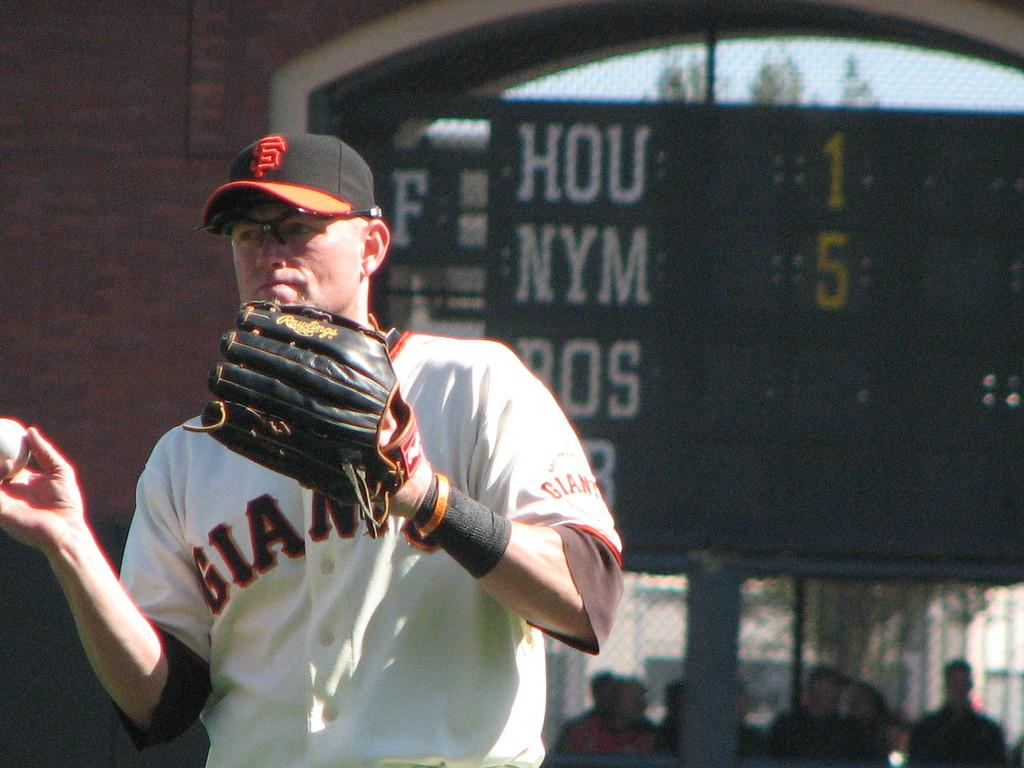Provide a one-sentence caption for the provided image. A San Francisco Giants baseball player with a catchers glove on one hand and a baseball in the other. 